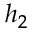<formula> <loc_0><loc_0><loc_500><loc_500>h _ { 2 }</formula> 